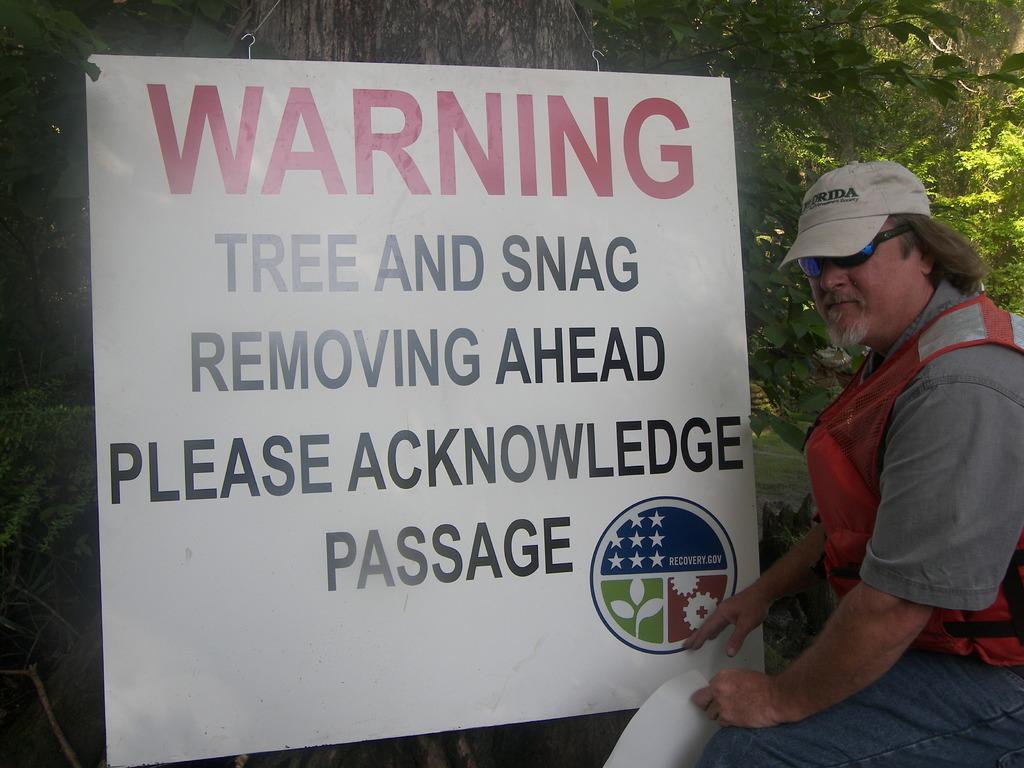In one or two sentences, can you explain what this image depicts? In this image there is the person wearing goggles, cap and holding a paper, there is a banner with some text hanging in the tree. 